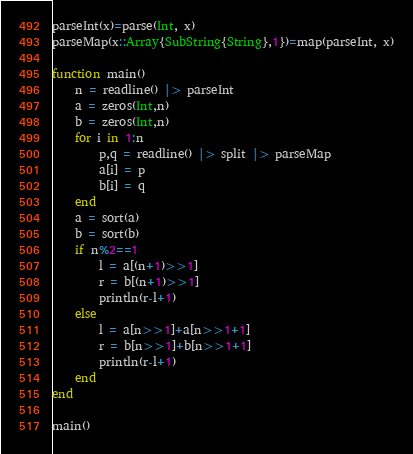Convert code to text. <code><loc_0><loc_0><loc_500><loc_500><_Julia_>parseInt(x)=parse(Int, x)
parseMap(x::Array{SubString{String},1})=map(parseInt, x)

function main()
	n = readline() |> parseInt
	a = zeros(Int,n)
	b = zeros(Int,n)
	for i in 1:n
		p,q = readline() |> split |> parseMap
		a[i] = p
		b[i] = q
	end
	a = sort(a)
	b = sort(b)
	if n%2==1
		l = a[(n+1)>>1]
		r = b[(n+1)>>1]
		println(r-l+1)
	else
		l = a[n>>1]+a[n>>1+1]
		r = b[n>>1]+b[n>>1+1]
		println(r-l+1)
	end
end

main()</code> 